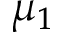<formula> <loc_0><loc_0><loc_500><loc_500>\mu _ { 1 }</formula> 